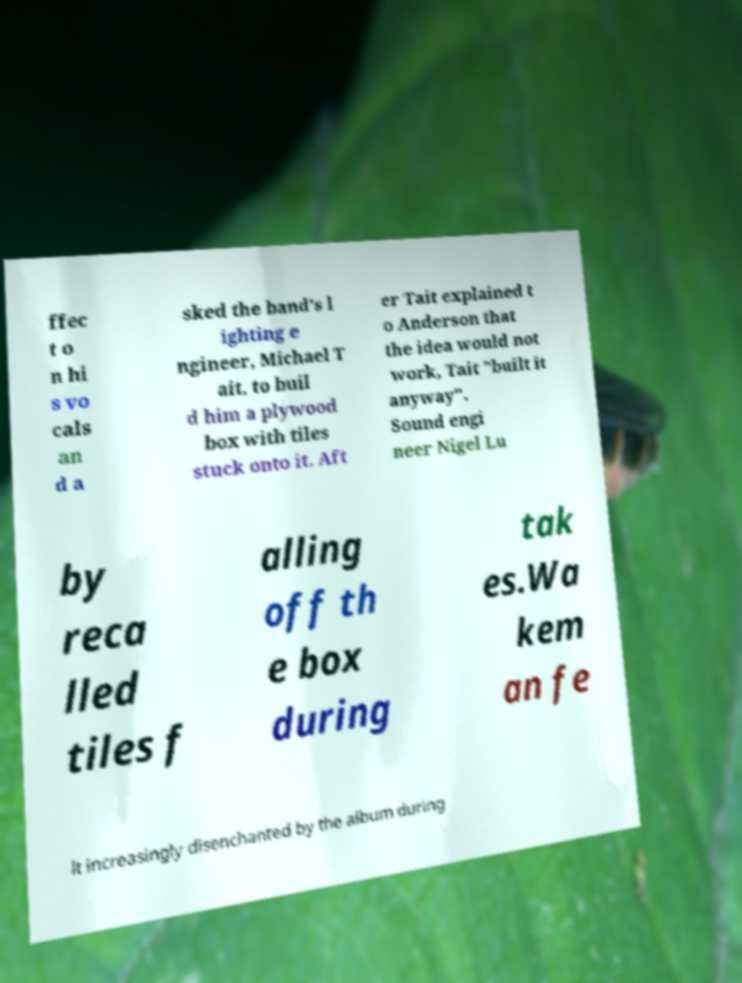Please identify and transcribe the text found in this image. ffec t o n hi s vo cals an d a sked the band's l ighting e ngineer, Michael T ait, to buil d him a plywood box with tiles stuck onto it. Aft er Tait explained t o Anderson that the idea would not work, Tait "built it anyway". Sound engi neer Nigel Lu by reca lled tiles f alling off th e box during tak es.Wa kem an fe lt increasingly disenchanted by the album during 